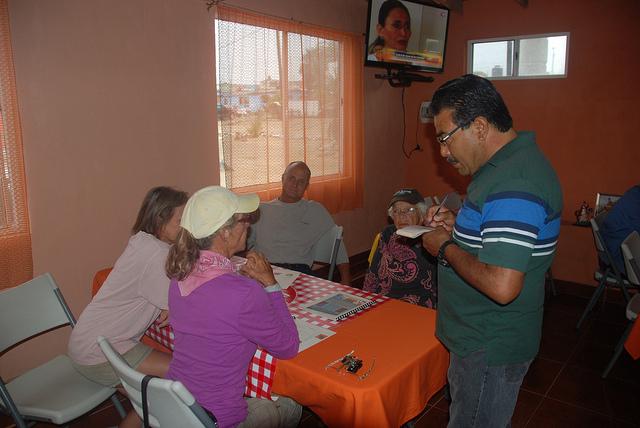Where is the equal sign?
Write a very short answer. Nowhere. Is there alcohol here?
Be succinct. No. Are the people sitting down children or adults?
Give a very brief answer. Adults. What color is the tablecloth?
Give a very brief answer. Orange. Are these co-workers in an office?
Short answer required. No. Where are they?
Keep it brief. Restaurant. Are they playing a funny game?
Short answer required. No. How many people are at the table?
Keep it brief. 4. Is the man helping the kid play the game?
Be succinct. No. Is there an envelope on the table?
Quick response, please. No. How many people are in this picture?
Keep it brief. 5. How many boys are in the photo?
Keep it brief. 2. Is this picture in color?
Give a very brief answer. Yes. Where is the menu written?
Concise answer only. Tablet. What type of TV is in the photo?
Quick response, please. Flat screen. How many people are seated?
Answer briefly. 4. Where are they playing video games?
Concise answer only. Restaurant. What is the man holding on his right hand?
Quick response, please. Pen. Is this man watching TV?
Be succinct. No. What is on the side of the woman's hat?
Answer briefly. Nothing. Are these people having fun?
Write a very short answer. Yes. How many bottles are on the table?
Short answer required. 0. What is the man wearing on his Face?
Concise answer only. Glasses. What is the white thing the man is holding?
Short answer required. Pad. Are this people playing?
Concise answer only. No. Are they having fun?
Keep it brief. Yes. Does this person look like he is balding?
Concise answer only. No. How many females are in the room?
Quick response, please. 3. What are the people doing?
Concise answer only. Ordering food. Is everyone getting the daily special?
Be succinct. No. Are they sitting outside?
Be succinct. No. What color are the walls?
Give a very brief answer. Pink. Does she have both of her elbows on the table?
Be succinct. Yes. Is there a plant in the window?
Give a very brief answer. No. What are they doing?
Concise answer only. Ordering food. What is the food for?
Keep it brief. Eating. Who is in the middle?
Be succinct. Woman. 